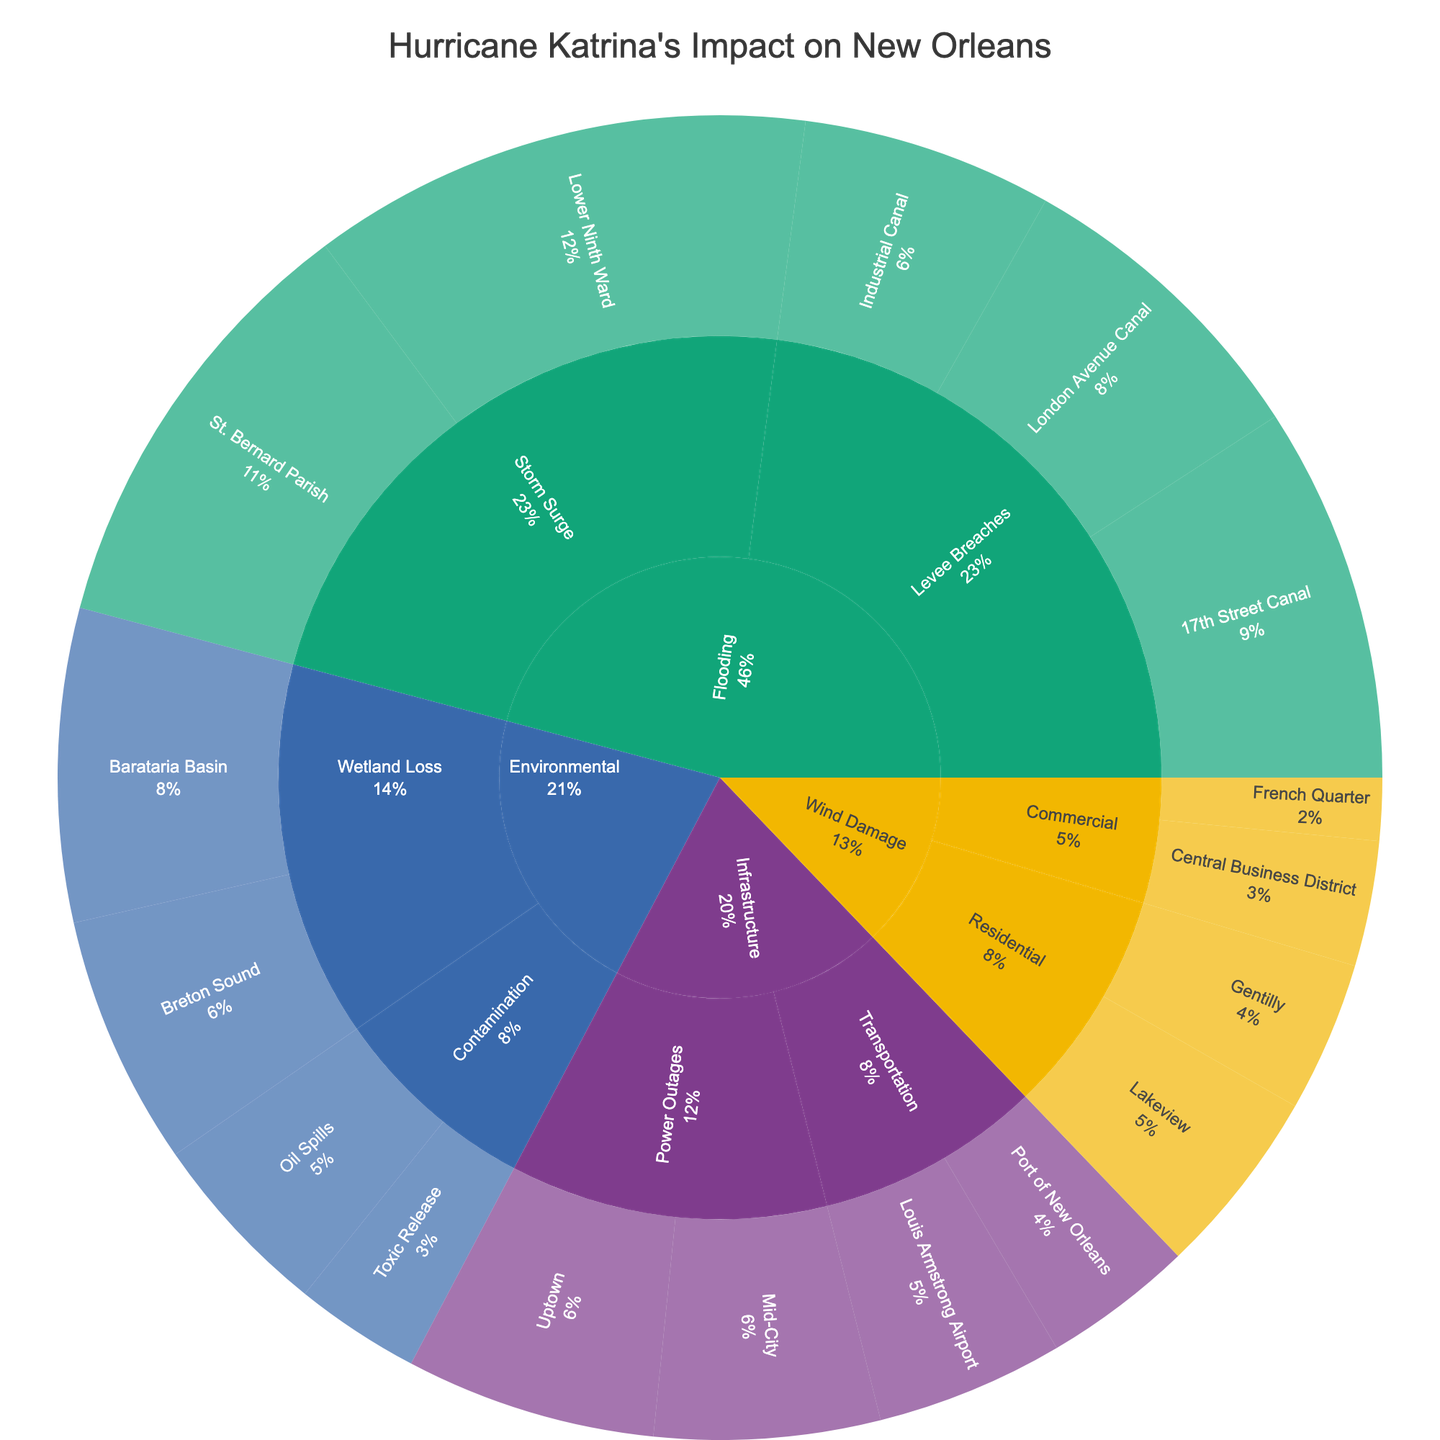Which category has the highest total impact in terms of area value? To determine this, sum the values for all subcategories and areas within each category. The highest total value represents the category with the greatest impact.
Answer: Flooding What is the total impact value of the 'Levee Breaches' subcategory? Add the values for all areas under the 'Levee Breaches' subcategory:
17th Street Canal (30) + London Avenue Canal (25) + Industrial Canal (20) = 75.
Answer: 75 Is the value of 'Storm Surge' in the 'Lower Ninth Ward' higher than 'St. Bernard Parish'? Compare the values directly: Lower Ninth Ward (40) vs. St. Bernard Parish (35). 40 is greater than 35.
Answer: Yes Which area within the 'Environmental' category has the least impact value? Compare the values of all areas under the 'Environmental' category:
Barataria Basin (25), Breton Sound (20), Oil Spills (15), Toxic Release (10). The smallest value is for Toxic Release.
Answer: Toxic Release What percentage of the 'Wind Damage' category is caused by 'Commercial' areas? Calculate the total value of 'Wind Damage': Residential (15 + 12) + Commercial (10 + 5) = 42. 
Then, find the value of 'Commercial' areas: 10 + 5 = 15.
Percentage is (15/42) * 100% = 35.7%.
Answer: 35.7% What are the combined values of 'Power Outages' in Uptown and Mid-City? Add the values for Power Outages in both areas: Uptown (20) + Mid-City (18). 
So the combined value is 20 + 18 = 38.
Answer: 38 How does 'Wetland Loss' compare to 'Contamination' in the 'Environmental' category in terms of impact value? Add the values within each subcategory: Wetland Loss (Barataria Basin (25) + Breton Sound (20) = 45), Contamination (Oil Spills (15) + Toxic Release (10) = 25).
Then, compare these totals: 45 vs. 25. Wetland Loss has a higher impact.
Answer: Wetland Loss has a higher impact Which area had the highest impact from flooding? Compare the individual area values for flooding subcategories 'Levee Breaches' and 'Storm Surge': 
Levee Breaches: 17th Street Canal (30), London Avenue Canal (25), Industrial Canal (20)
Storm Surge: Lower Ninth Ward (40), St. Bernard Parish (35).
Lower Ninth Ward has the highest impact value of 40.
Answer: Lower Ninth Ward What is the sum of the impacts from all areas within the 'Infrastructure' category? Sum the values for all areas within the 'Infrastructure' category:
Power Outages: Uptown (20) + Mid-City (18) = 38
Transportation: Louis Armstrong Airport (15) + Port of New Orleans (12) = 27.
Total is 38 + 27 = 65.
Answer: 65 